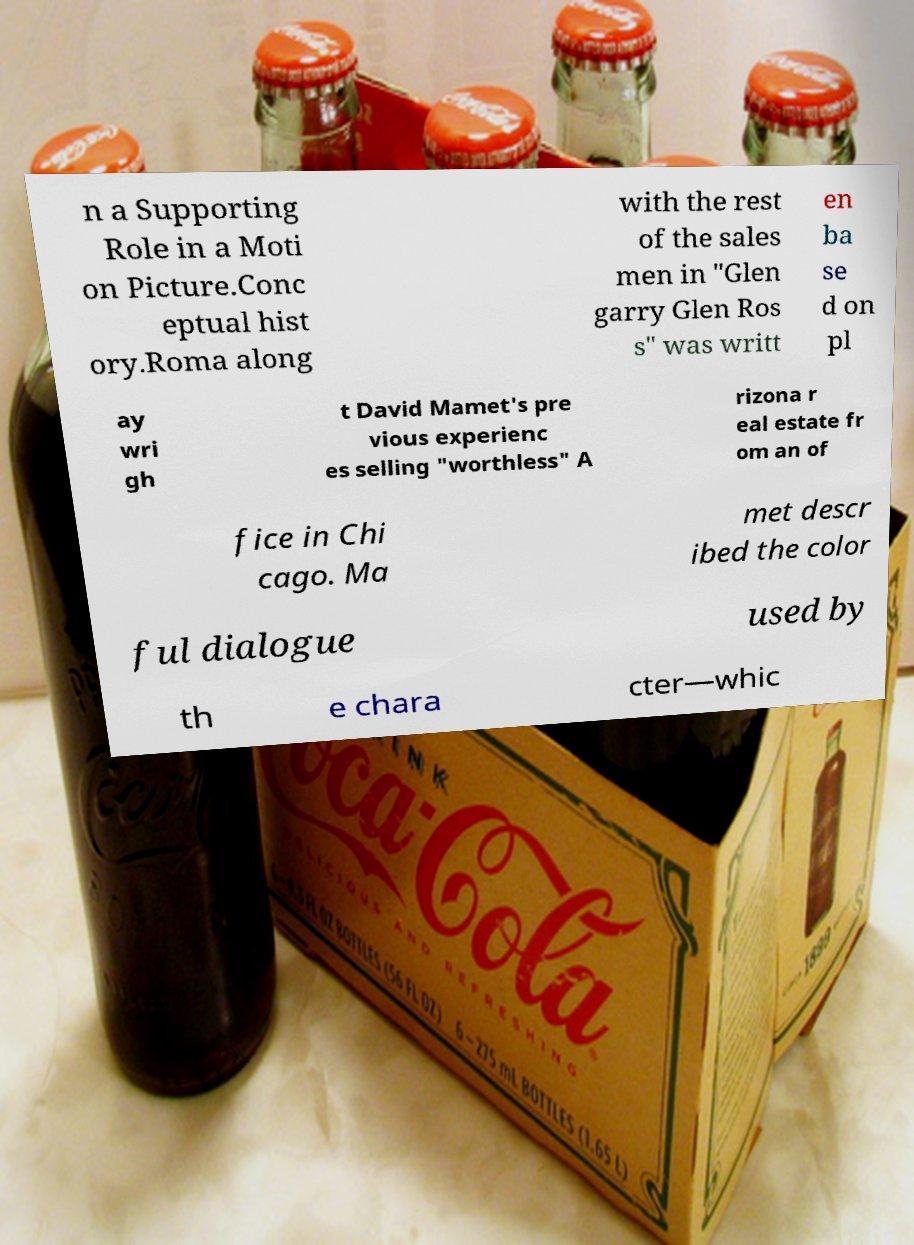Can you read and provide the text displayed in the image?This photo seems to have some interesting text. Can you extract and type it out for me? n a Supporting Role in a Moti on Picture.Conc eptual hist ory.Roma along with the rest of the sales men in "Glen garry Glen Ros s" was writt en ba se d on pl ay wri gh t David Mamet's pre vious experienc es selling "worthless" A rizona r eal estate fr om an of fice in Chi cago. Ma met descr ibed the color ful dialogue used by th e chara cter—whic 